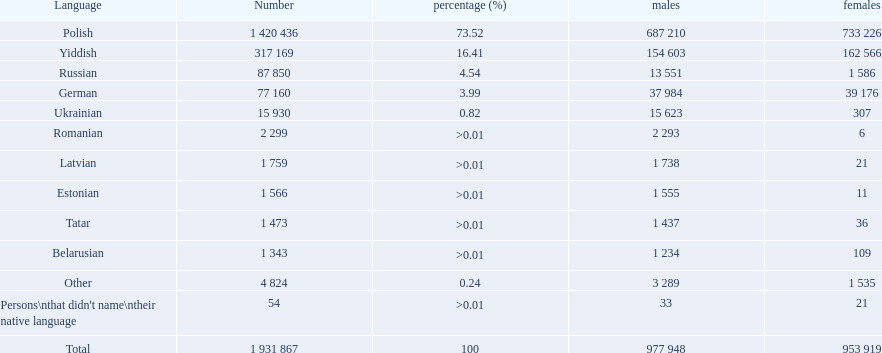What is the count of languages worldwide? Polish, Yiddish, Russian, German, Ukrainian, Romanian, Latvian, Estonian, Tatar, Belarusian. Which language is most widely spoken? Polish. 